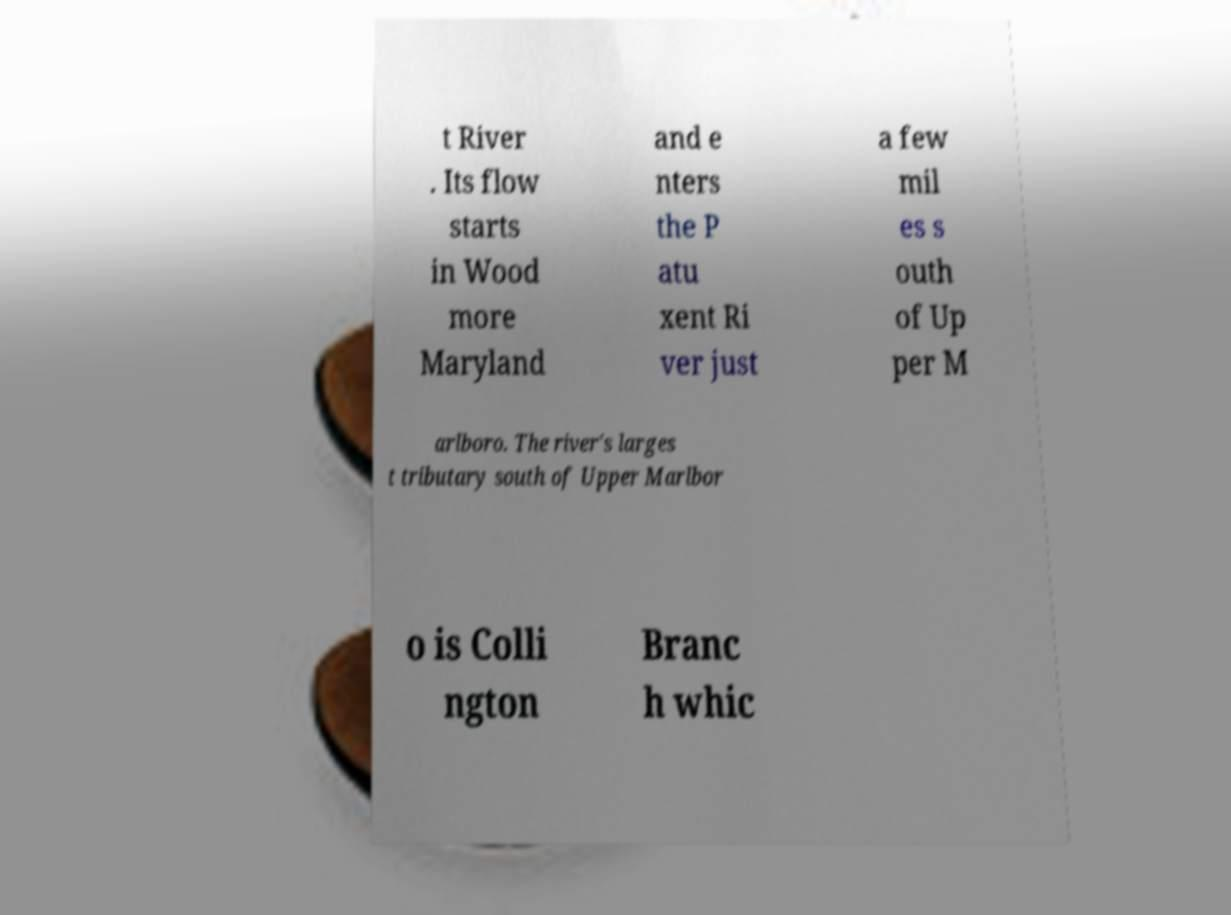Can you read and provide the text displayed in the image?This photo seems to have some interesting text. Can you extract and type it out for me? t River . Its flow starts in Wood more Maryland and e nters the P atu xent Ri ver just a few mil es s outh of Up per M arlboro. The river's larges t tributary south of Upper Marlbor o is Colli ngton Branc h whic 